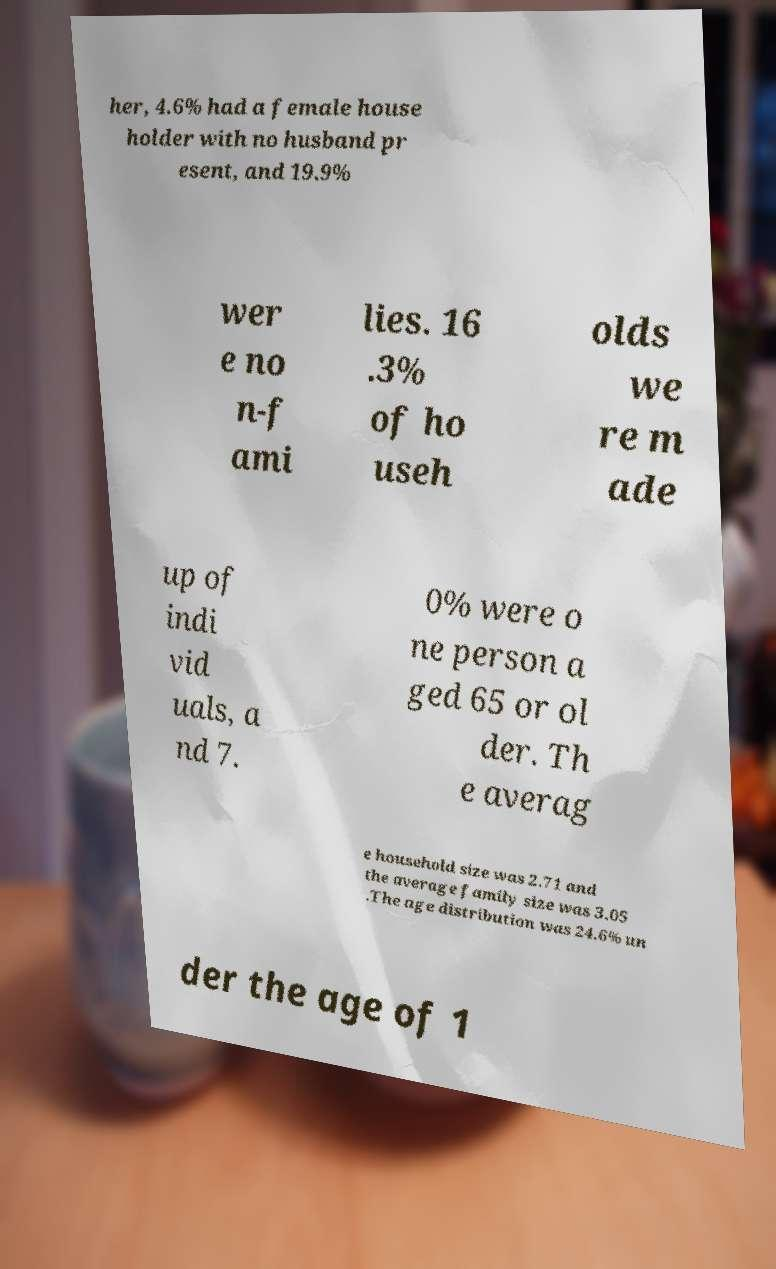Could you assist in decoding the text presented in this image and type it out clearly? her, 4.6% had a female house holder with no husband pr esent, and 19.9% wer e no n-f ami lies. 16 .3% of ho useh olds we re m ade up of indi vid uals, a nd 7. 0% were o ne person a ged 65 or ol der. Th e averag e household size was 2.71 and the average family size was 3.05 .The age distribution was 24.6% un der the age of 1 